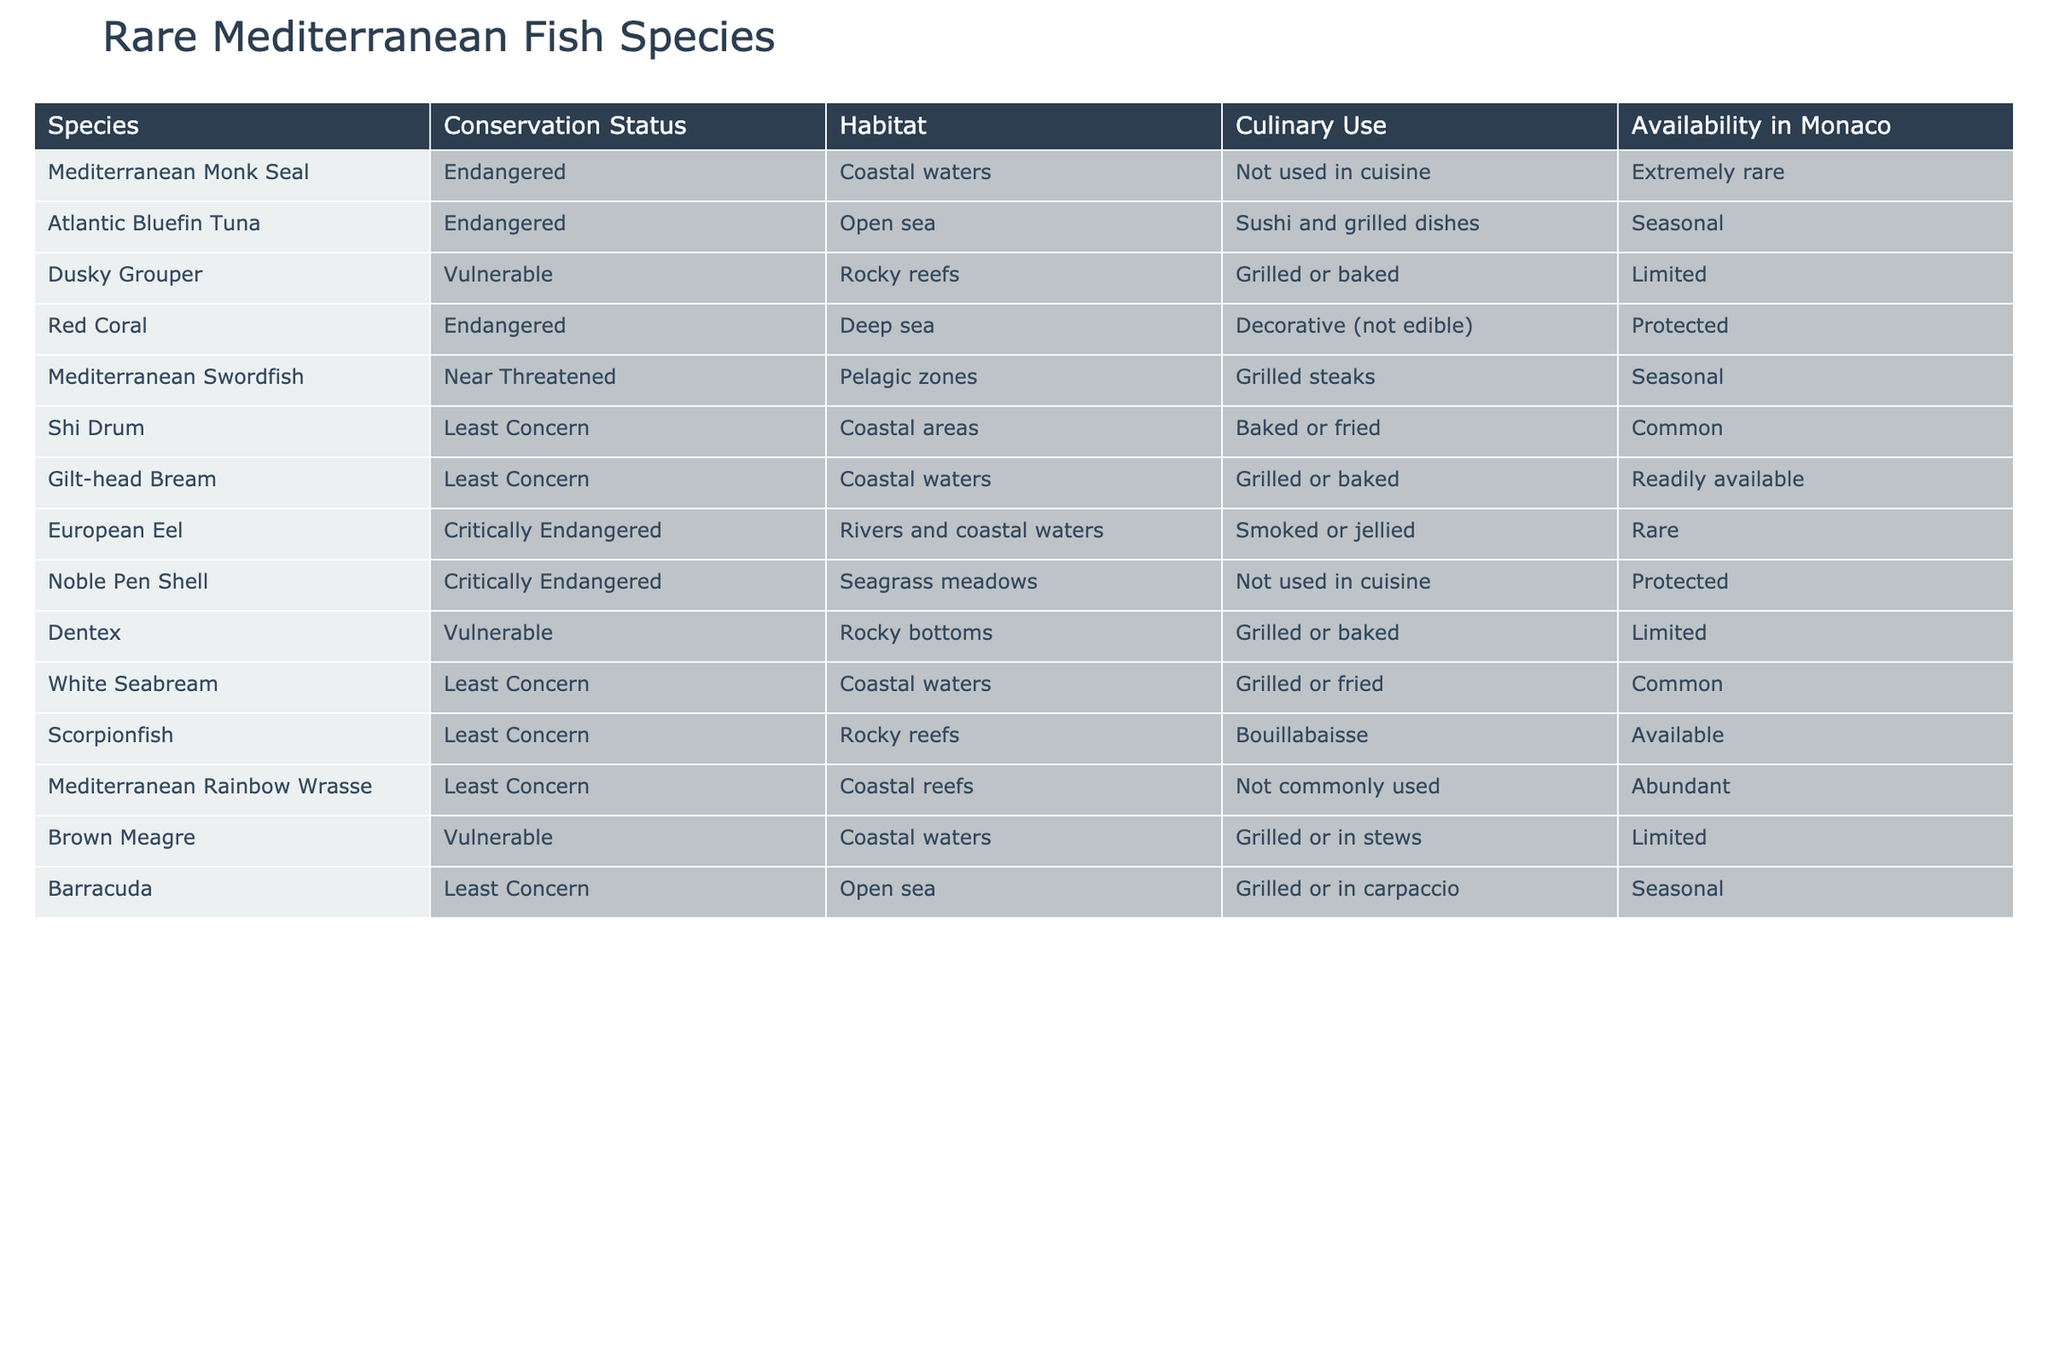What is the conservation status of the European Eel? The table lists 'European Eel' under the 'Species' column, and the corresponding 'Conservation Status' is 'Critically Endangered'.
Answer: Critically Endangered Which fish species are marked as 'Least Concern'? The species listed under the 'Conservation Status' as 'Least Concern' are Shi Drum, Gilt-head Bream, White Seabream, Scorpionfish, and Mediterranean Rainbow Wrasse.
Answer: Shi Drum, Gilt-head Bream, White Seabream, Scorpionfish, Mediterranean Rainbow Wrasse How many species are classified as 'Endangered'? The table reveals three species marked as 'Endangered': Mediterranean Monk Seal, Atlantic Bluefin Tuna, and Red Coral.
Answer: Three Are there any fish species in the table that are protected? The entries for Red Coral and Noble Pen Shell indicate they are 'Protected', confirming that these species fall under conservation measures.
Answer: Yes Which species are available seasonally in Monaco? The species labeled with 'Seasonal' availability are Atlantic Bluefin Tuna, Mediterranean Swordfish, and Barracuda.
Answer: Atlantic Bluefin Tuna, Mediterranean Swordfish, Barracuda What is the habitat of the Dusky Grouper? By referencing the nutrient in the 'Habitat' column next to 'Dusky Grouper', it shows 'Rocky reefs' as the habitat.
Answer: Rocky reefs Count how many species are available in Monaco? The availability in Monaco shows that Shi Drum, Gilt-head Bream, White Seabream, Scorpionfish, and Mediterranean Rainbow Wrasse are classified as 'Common', while others are 'Available', 'Limited', or 'Rare', bringing the total available species to eight.
Answer: Eight Which fish species have a culinary use of being grilled or baked? The culinary uses listed are for Dusky Grouper, Dentex, Brown Meagre, Gilt-head Bream, and White Seabream; all these species have 'Grilled or baked' as a culinary description.
Answer: Dusky Grouper, Dentex, Brown Meagre, Gilt-head Bream, White Seabream Is there any fish species listed that should not be used in cuisine? The Mediterranean Monk Seal and Noble Pen Shell are noted as not being used in cuisine according to the table's descriptions.
Answer: Yes What is the most critically endangered species listed? The table shows that both the European Eel and the Noble Pen Shell are categorized as 'Critically Endangered', indicating they are among the most endangered species in the list.
Answer: European Eel, Noble Pen Shell 